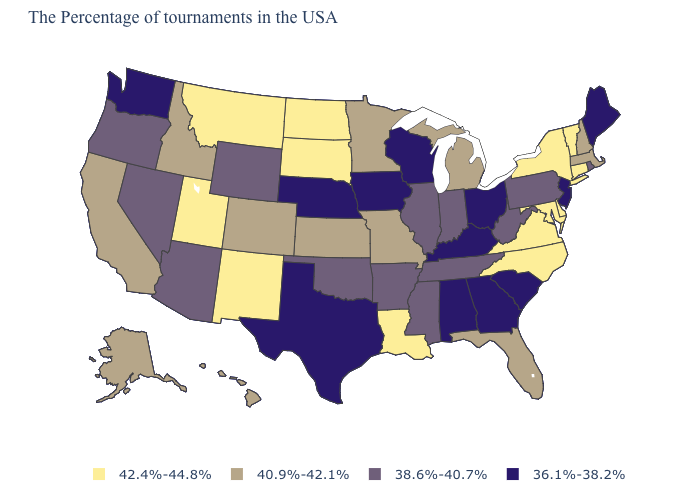What is the value of Arkansas?
Short answer required. 38.6%-40.7%. What is the value of South Carolina?
Give a very brief answer. 36.1%-38.2%. What is the lowest value in the USA?
Be succinct. 36.1%-38.2%. What is the lowest value in the USA?
Short answer required. 36.1%-38.2%. What is the lowest value in the West?
Give a very brief answer. 36.1%-38.2%. Among the states that border Montana , which have the lowest value?
Concise answer only. Wyoming. Name the states that have a value in the range 40.9%-42.1%?
Give a very brief answer. Massachusetts, New Hampshire, Florida, Michigan, Missouri, Minnesota, Kansas, Colorado, Idaho, California, Alaska, Hawaii. Which states have the highest value in the USA?
Short answer required. Vermont, Connecticut, New York, Delaware, Maryland, Virginia, North Carolina, Louisiana, South Dakota, North Dakota, New Mexico, Utah, Montana. Does Massachusetts have a higher value than Illinois?
Give a very brief answer. Yes. Does Idaho have a lower value than Alaska?
Give a very brief answer. No. What is the value of Utah?
Write a very short answer. 42.4%-44.8%. Does Kansas have a higher value than Kentucky?
Answer briefly. Yes. What is the highest value in the USA?
Write a very short answer. 42.4%-44.8%. Does Texas have the same value as Indiana?
Write a very short answer. No. What is the value of Utah?
Keep it brief. 42.4%-44.8%. 